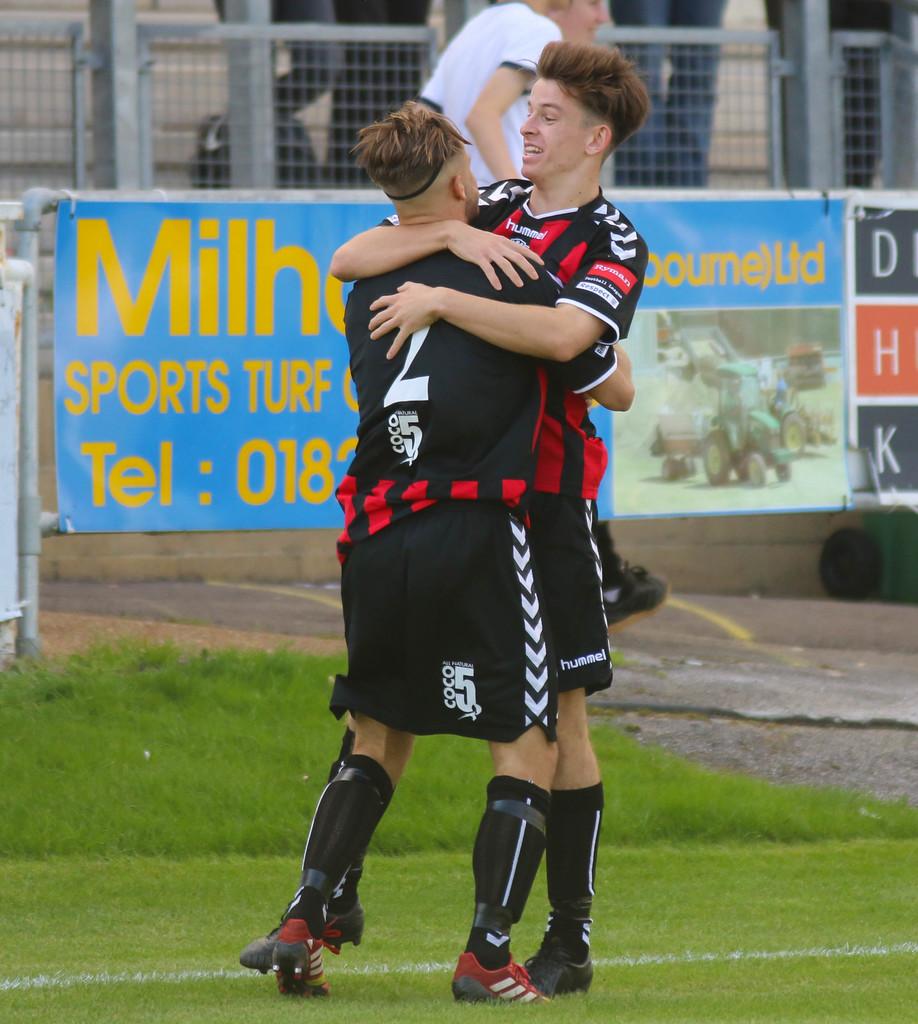What banner is the advertisement?
Keep it short and to the point. Sports turf. 